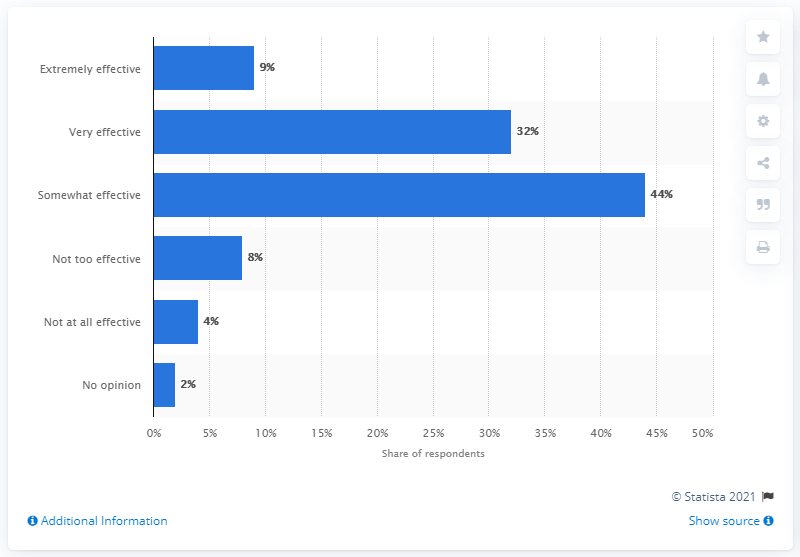Point out several critical features in this image. According to the survey, 9% of respondents believe that the TSA is extremely effective at preventing acts of terrorism on airplanes. 